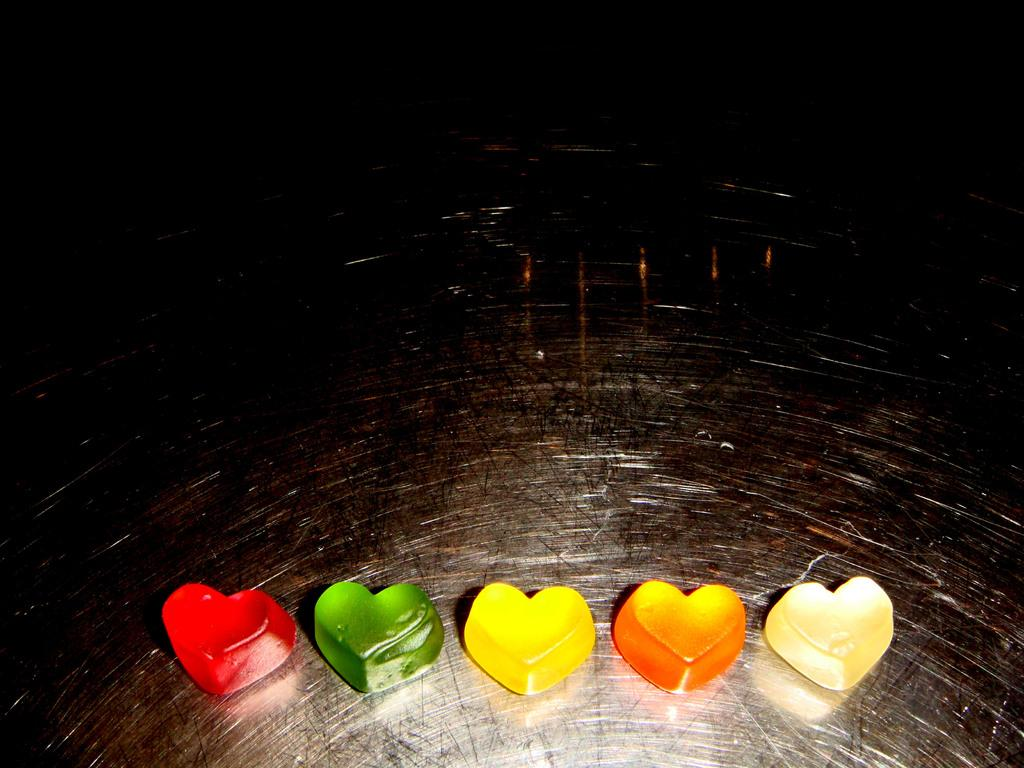What type of items can be seen in the image? There are colorful candies in the image. Can you describe the appearance of the candies? The candies are colorful, which suggests they come in various shades and hues. What might be the purpose of these candies? The purpose of these candies could be for consumption or decoration, but without more context, it's difficult to determine their exact use. What type of ant can be seen crawling on the candies in the image? There are no ants present in the image; it only features colorful candies. 